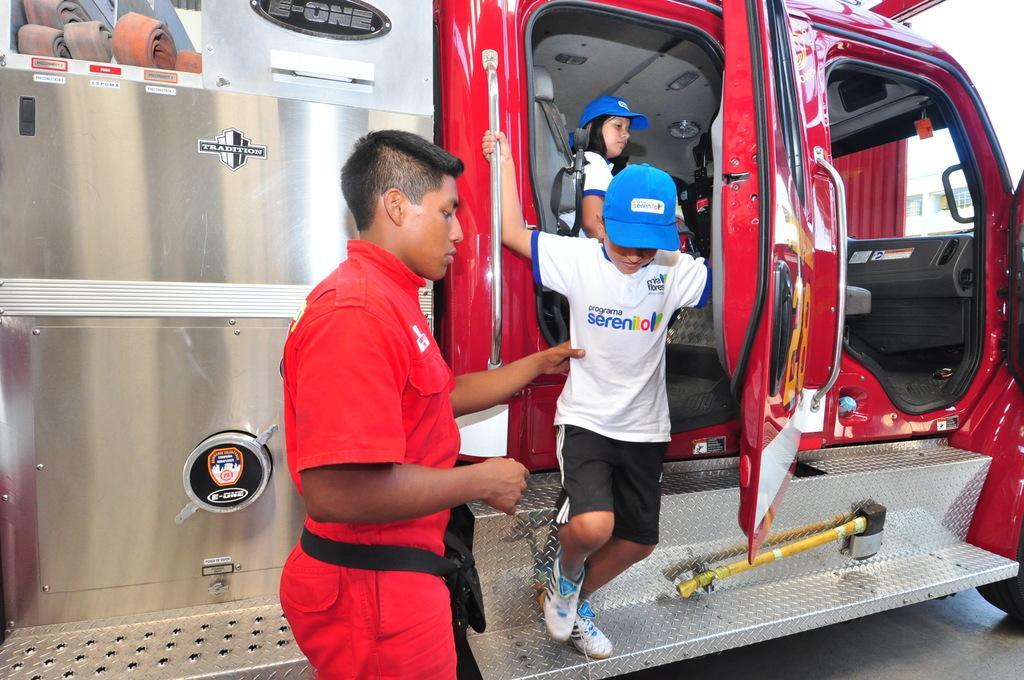Can you describe this image briefly? In this picture we can see a truck and three people, a man is wearing red color shirt and a woman is seated in the truck. 